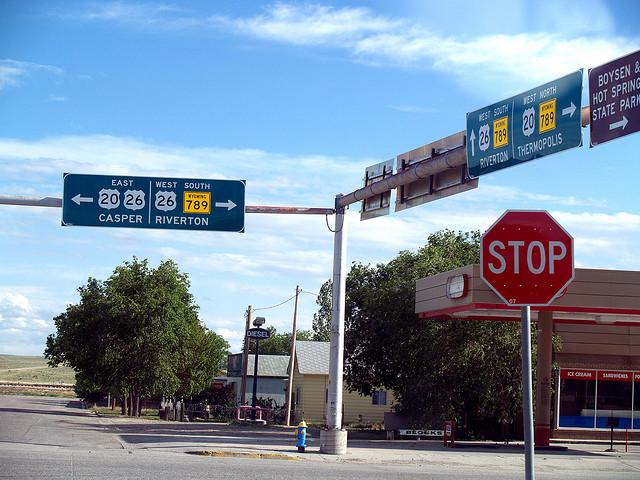What building does the diesel sign most likely foreshadow? Please explain your reasoning. gas station. The diesel sign indicates a gas station is nearby. 